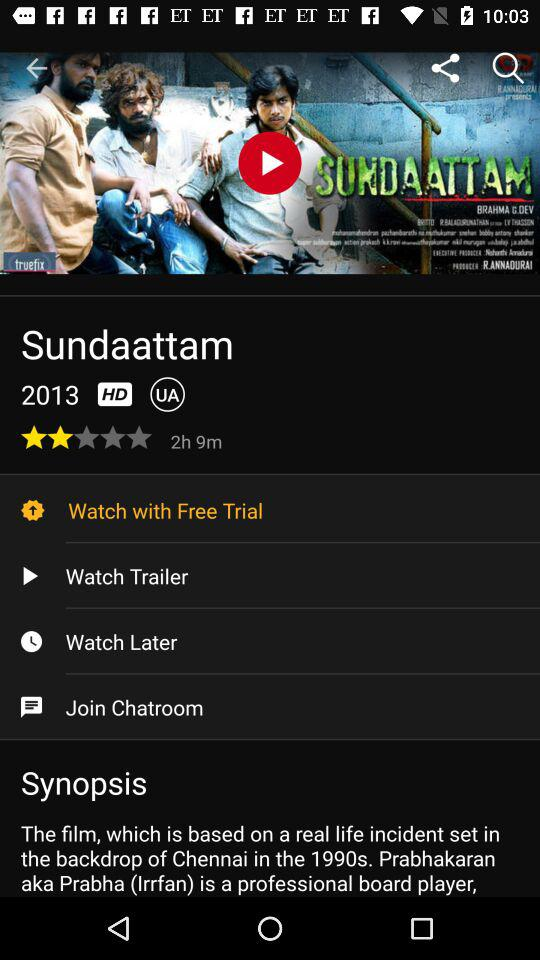How long is this movie? The length of this movie is 2 hours and 9 minutes. 